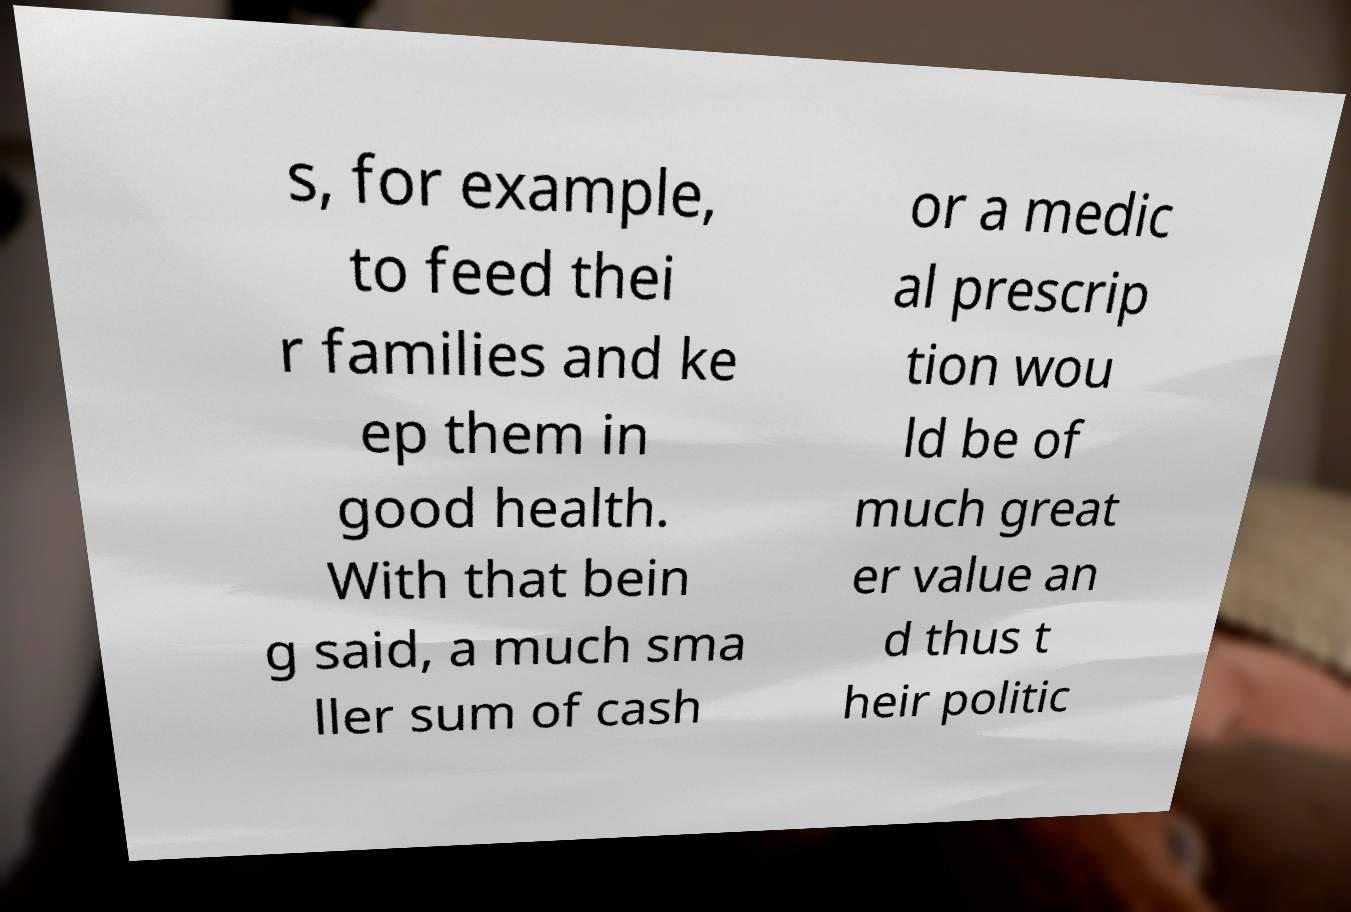Can you accurately transcribe the text from the provided image for me? s, for example, to feed thei r families and ke ep them in good health. With that bein g said, a much sma ller sum of cash or a medic al prescrip tion wou ld be of much great er value an d thus t heir politic 